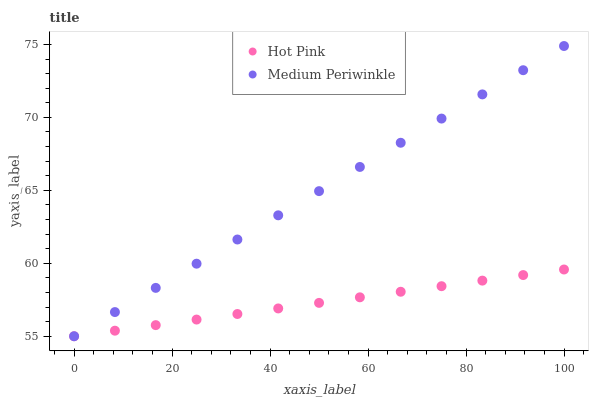Does Hot Pink have the minimum area under the curve?
Answer yes or no. Yes. Does Medium Periwinkle have the maximum area under the curve?
Answer yes or no. Yes. Does Medium Periwinkle have the minimum area under the curve?
Answer yes or no. No. Is Hot Pink the smoothest?
Answer yes or no. Yes. Is Medium Periwinkle the roughest?
Answer yes or no. Yes. Is Medium Periwinkle the smoothest?
Answer yes or no. No. Does Hot Pink have the lowest value?
Answer yes or no. Yes. Does Medium Periwinkle have the highest value?
Answer yes or no. Yes. Does Medium Periwinkle intersect Hot Pink?
Answer yes or no. Yes. Is Medium Periwinkle less than Hot Pink?
Answer yes or no. No. Is Medium Periwinkle greater than Hot Pink?
Answer yes or no. No. 